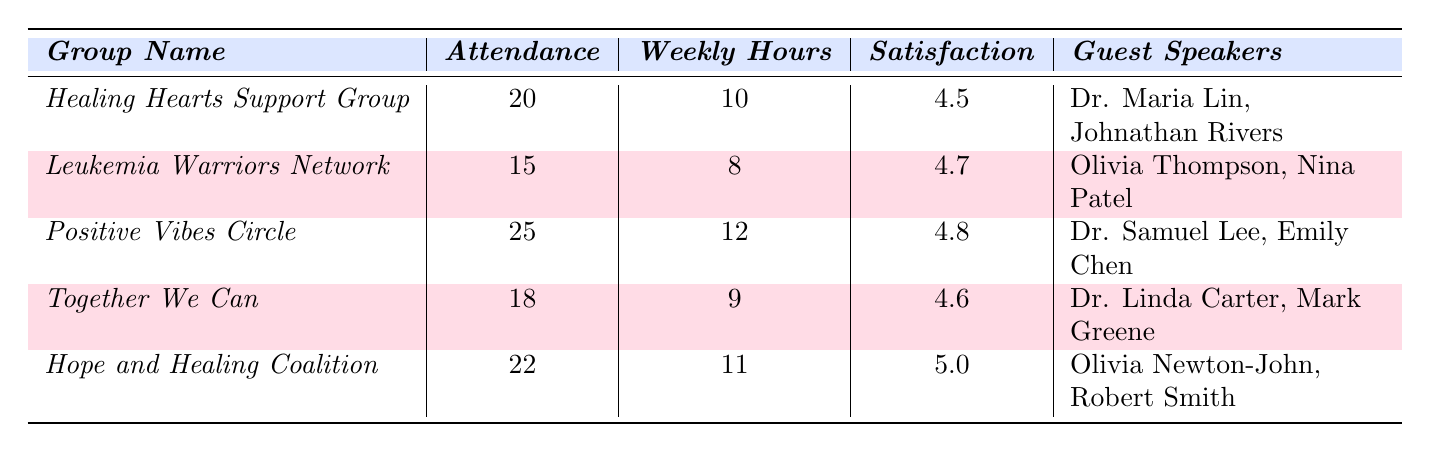What is the highest member satisfaction rating among the support groups? The table lists the member satisfaction ratings for each group. The highest value is 5.0 for the "Hope and Healing Coalition."
Answer: 5.0 How many total attendees are there across all support groups? Adding the attendance of each group: 20 + 15 + 25 + 18 + 22 = 100.
Answer: 100 Which support group had the least attendance? Looking at the attendance numbers, "Leukemia Warriors Network" has the lowest attendance with 15 members.
Answer: Leukemia Warriors Network What is the average weekly engagement hours across all groups? Calculate the total weekly engagement hours: 10 + 8 + 12 + 9 + 11 = 50. There are 5 groups, so the average is 50 / 5 = 10.
Answer: 10 Which group has guest speakers that include Olivia Newton-John? In the table, "Hope and Healing Coalition" lists Olivia Newton-John among its guest speakers.
Answer: Hope and Healing Coalition Is the member satisfaction rating for the "Positive Vibes Circle" higher than 4.5? The satisfaction rating for "Positive Vibes Circle" is 4.8, which is higher than 4.5.
Answer: Yes What is the difference in attendance between "Positive Vibes Circle" and "Leukemia Warriors Network"? "Positive Vibes Circle" has an attendance of 25 while "Leukemia Warriors Network" has 15. The difference is 25 - 15 = 10.
Answer: 10 Which support group has the highest number of weekly engagement hours? The "Positive Vibes Circle" has 12 weekly engagement hours, which is the highest among the groups.
Answer: Positive Vibes Circle How many guest speakers are there in total across all support groups? Counting the guest speakers individually: Healing Hearts Support Group (2) + Leukemia Warriors Network (2) + Positive Vibes Circle (2) + Together We Can (2) + Hope and Healing Coalition (2) = 10 guest speakers.
Answer: 10 Is the average member satisfaction rating above 4.5? The average is calculated as follows: (4.5 + 4.7 + 4.8 + 4.6 + 5.0) / 5 = 4.66, which is above 4.5.
Answer: Yes 